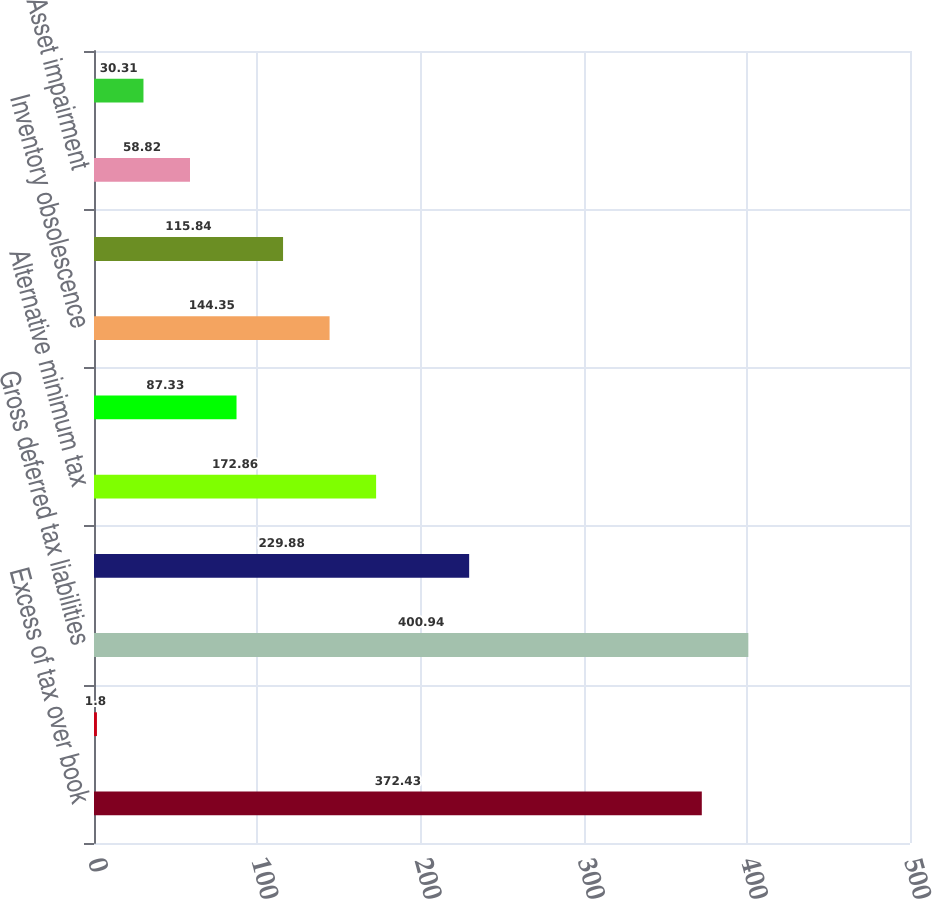Convert chart to OTSL. <chart><loc_0><loc_0><loc_500><loc_500><bar_chart><fcel>Excess of tax over book<fcel>Other - net<fcel>Gross deferred tax liabilities<fcel>Frequent flyer program<fcel>Alternative minimum tax<fcel>Leased aircraft return<fcel>Inventory obsolescence<fcel>Deferred revenue<fcel>Asset impairment<fcel>Employee benefits<nl><fcel>372.43<fcel>1.8<fcel>400.94<fcel>229.88<fcel>172.86<fcel>87.33<fcel>144.35<fcel>115.84<fcel>58.82<fcel>30.31<nl></chart> 